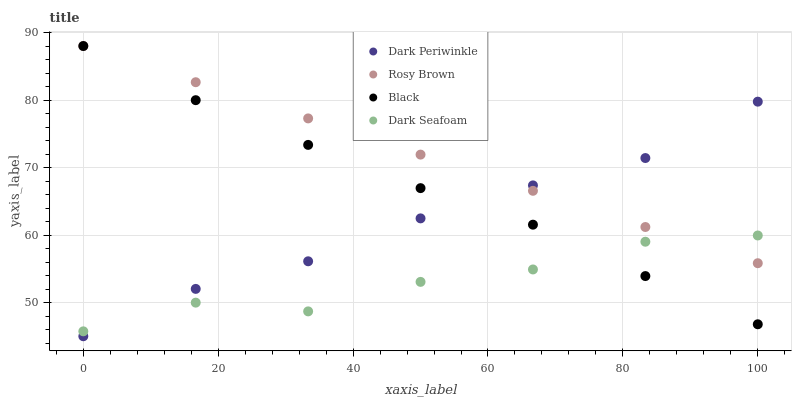Does Dark Seafoam have the minimum area under the curve?
Answer yes or no. Yes. Does Rosy Brown have the maximum area under the curve?
Answer yes or no. Yes. Does Black have the minimum area under the curve?
Answer yes or no. No. Does Black have the maximum area under the curve?
Answer yes or no. No. Is Rosy Brown the smoothest?
Answer yes or no. Yes. Is Dark Seafoam the roughest?
Answer yes or no. Yes. Is Black the smoothest?
Answer yes or no. No. Is Black the roughest?
Answer yes or no. No. Does Dark Periwinkle have the lowest value?
Answer yes or no. Yes. Does Black have the lowest value?
Answer yes or no. No. Does Black have the highest value?
Answer yes or no. Yes. Does Dark Periwinkle have the highest value?
Answer yes or no. No. Does Dark Periwinkle intersect Rosy Brown?
Answer yes or no. Yes. Is Dark Periwinkle less than Rosy Brown?
Answer yes or no. No. Is Dark Periwinkle greater than Rosy Brown?
Answer yes or no. No. 